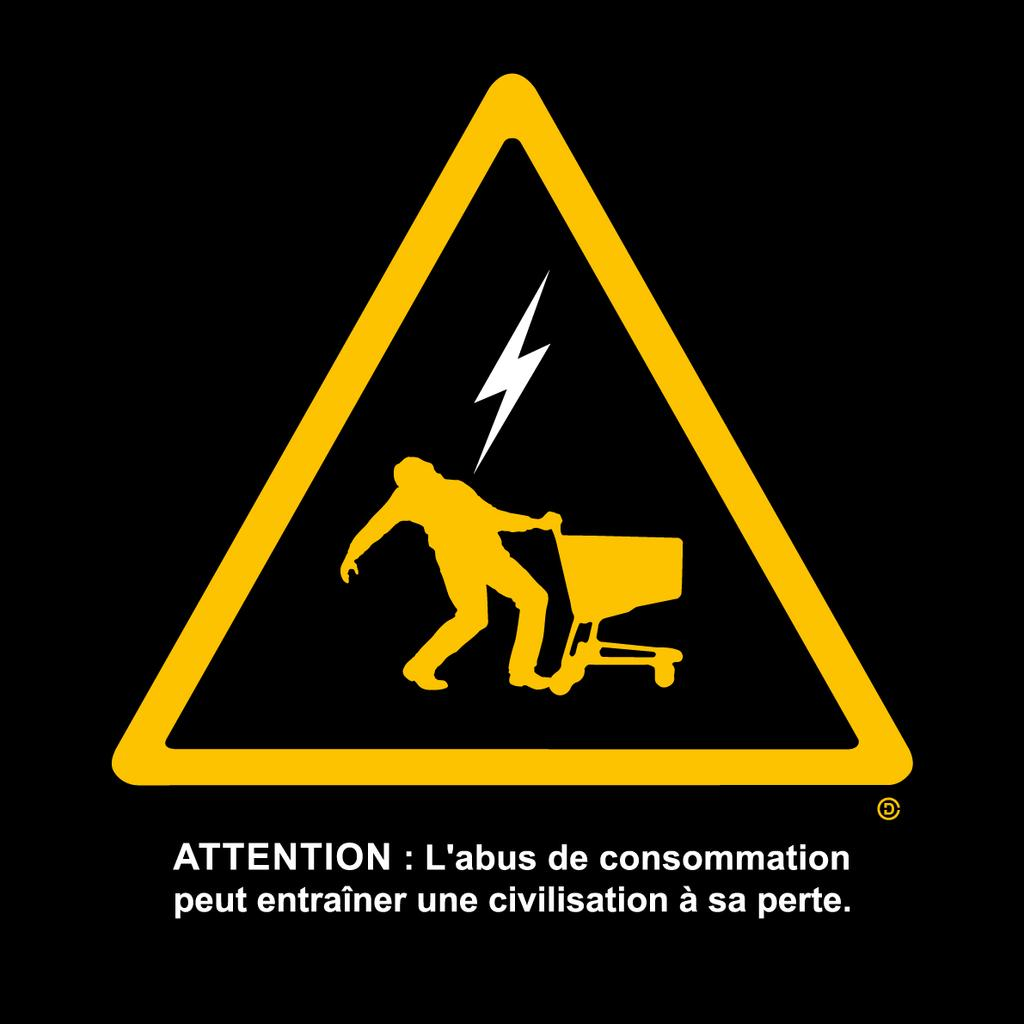<image>
Render a clear and concise summary of the photo. A caution sign with someone being electricuted while pushing a trolly, which begins with ATTENTION 